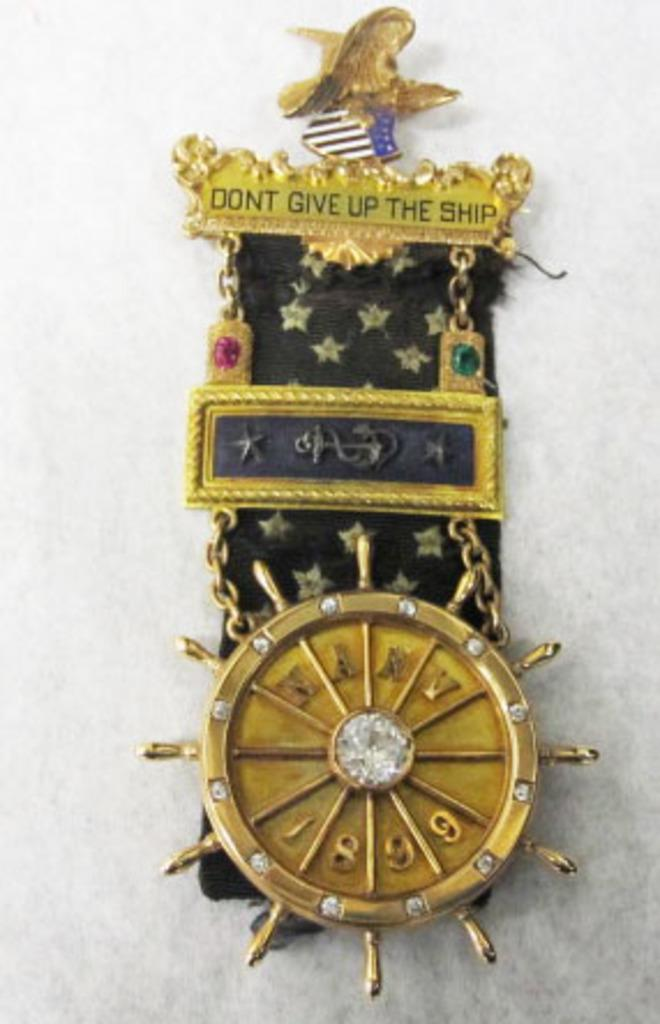Provide a one-sentence caption for the provided image. a watch that says to not give up the ship. 